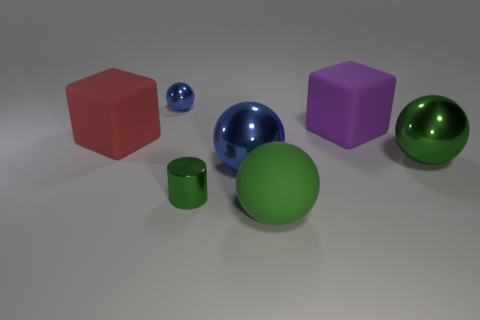Add 2 big green shiny objects. How many objects exist? 9 Subtract all cylinders. How many objects are left? 6 Add 1 large blue metal spheres. How many large blue metal spheres exist? 2 Subtract 0 green cubes. How many objects are left? 7 Subtract all purple rubber objects. Subtract all small rubber objects. How many objects are left? 6 Add 5 tiny metal cylinders. How many tiny metal cylinders are left? 6 